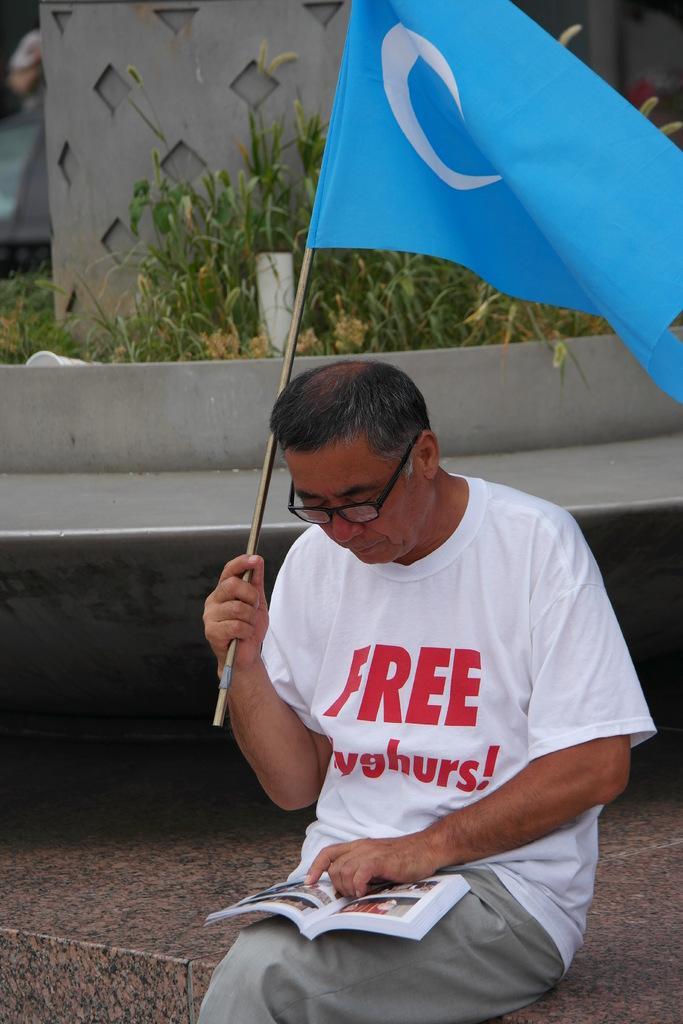Can you describe this image briefly? There is a person wearing specs is holding a flag and sitting. He is holding a book on the lap. In the back there are grasses. Also there is a small wall. 